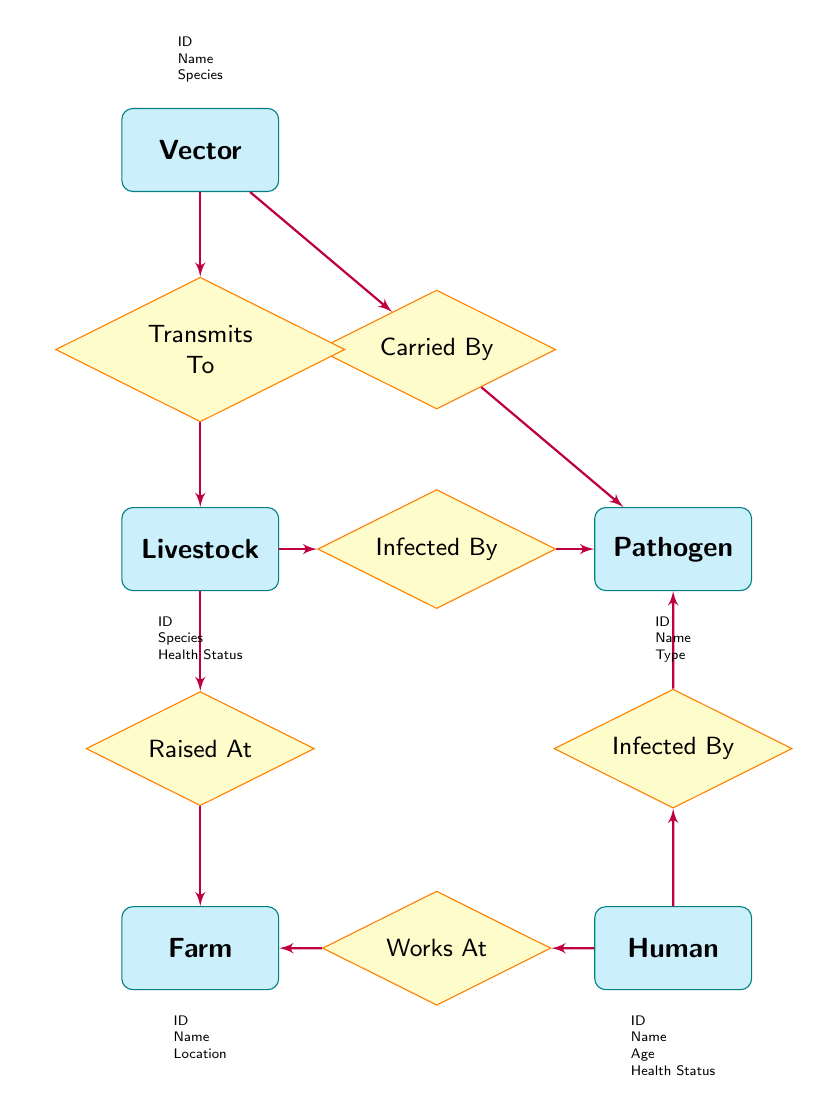What is the relationship between Livestock and Pathogen? The diagram shows the relationship labeled "Infected By" connecting the Livestock and Pathogen entities. This indicates that livestock can become infected by various pathogens.
Answer: Infected By How many entities are there in the diagram? By counting the distinct entities represented in the diagram, we have Livestock, Pathogen, Vector, Farm, and Human, leading to a total of five entities.
Answer: 5 What attribute is associated with the Vector entity? The attributes of the Vector entity are listed as Vector_ID, Name, and Species, which provide basic identification and classification information.
Answer: Vector_ID, Name, Species Which entity is connected to Farm via the "Raised At" relationship? The diagram indicates that the relationship "Raised At" connects the Livestock entity to the Farm entity. This signifies where livestock is typically raised.
Answer: Livestock What is transmitted from Vector to Livestock? The diagram clearly shows that the Vector transmits pathogens to the Livestock, highlighting an important pathway for disease transfer.
Answer: Pathogen How does a Human become infected with a Pathogen according to the diagram? The diagram depicts a relationship called "Infected By" that connects Humans to Pathogens. This means a human can become infected by pathogens just like livestock.
Answer: Infected By What is the role of the Human in relation to the Farm? The relationship "Works At" illustrates that Humans have a connection to Farms indicating they work there, which may influence their exposure to pathogens.
Answer: Works At Which relationship describes how Vector interacts with Pathogen? The relationship labeled "Carried By" describes how Vector can carry pathogens, establishing the role of vectors in pathogen transmission.
Answer: Carried By What information is provided about the severity of infection in the diagram? The diagram indicates that both the "Infected By" relationships (from Livestock to Pathogen and from Human to Pathogen) include the attribute “Severity,” suggesting that this concept is captured for these infections.
Answer: Severity 